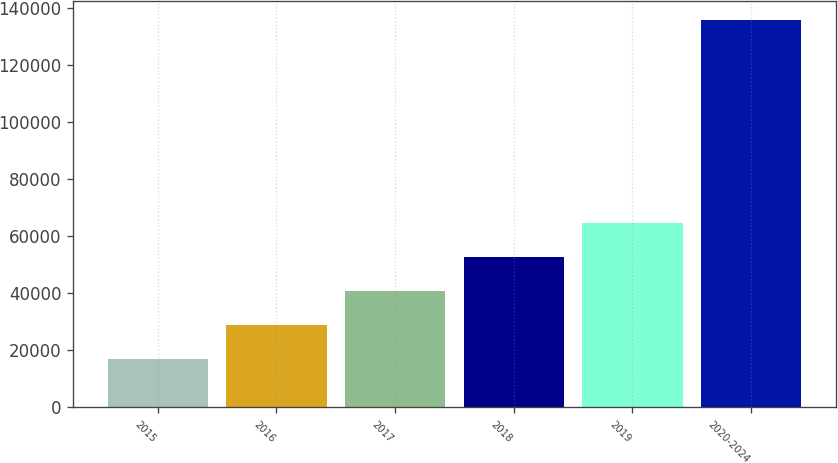Convert chart to OTSL. <chart><loc_0><loc_0><loc_500><loc_500><bar_chart><fcel>2015<fcel>2016<fcel>2017<fcel>2018<fcel>2019<fcel>2020-2024<nl><fcel>17103<fcel>28959<fcel>40815<fcel>52671<fcel>64527<fcel>135663<nl></chart> 